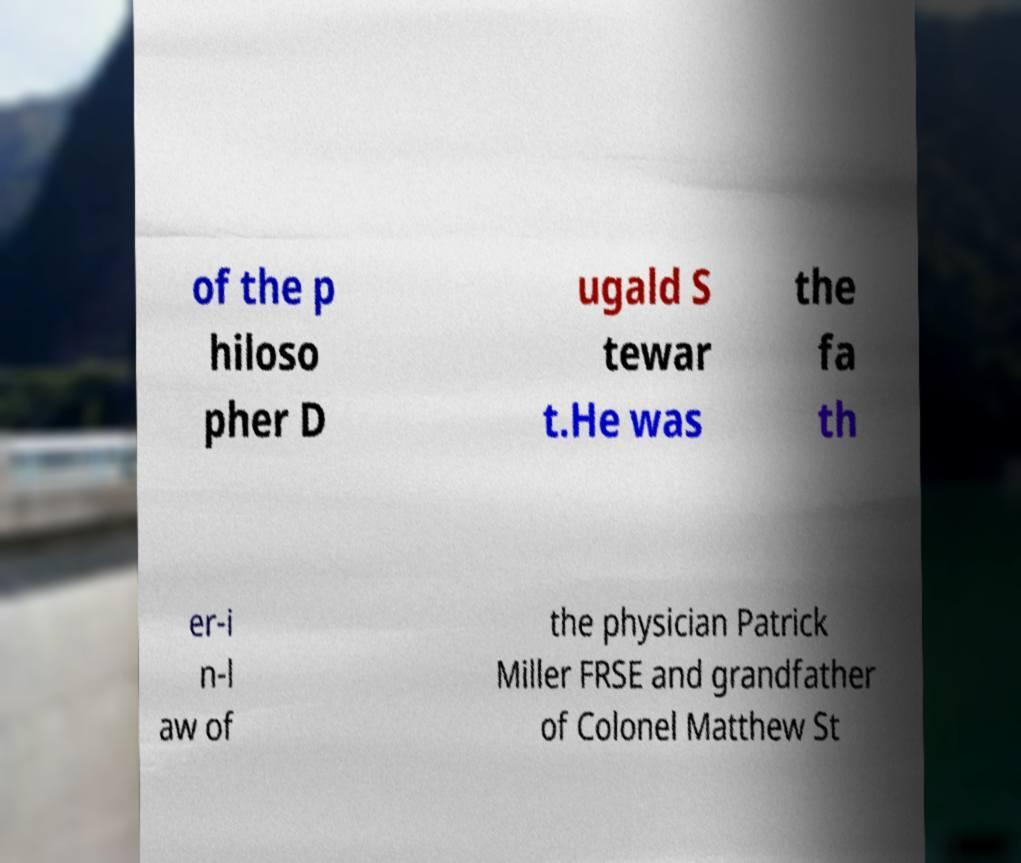There's text embedded in this image that I need extracted. Can you transcribe it verbatim? of the p hiloso pher D ugald S tewar t.He was the fa th er-i n-l aw of the physician Patrick Miller FRSE and grandfather of Colonel Matthew St 